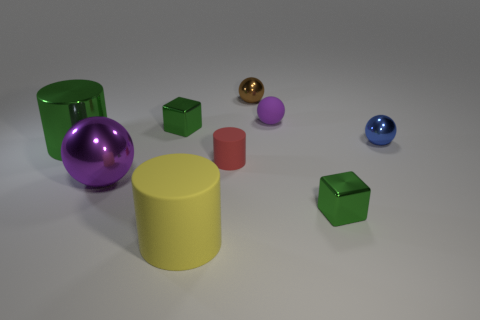What number of big objects are either yellow rubber things or purple metal balls?
Your answer should be very brief. 2. What number of blue shiny things are the same shape as the purple matte thing?
Your response must be concise. 1. There is a green cube that is on the right side of the small green object behind the big metal cylinder; what is its material?
Offer a terse response. Metal. Are there the same number of small gray spheres and tiny blue things?
Offer a very short reply. No. What size is the purple sphere that is in front of the small matte cylinder?
Your answer should be compact. Large. How many green things are either small metal blocks or large cylinders?
Your answer should be compact. 3. Are there any other things that have the same material as the blue sphere?
Offer a very short reply. Yes. There is a brown thing that is the same shape as the small blue thing; what is it made of?
Keep it short and to the point. Metal. Are there an equal number of big green metallic cylinders in front of the blue metal ball and blue metal things?
Your response must be concise. Yes. How big is the metal thing that is right of the brown metal object and in front of the tiny matte cylinder?
Give a very brief answer. Small. 